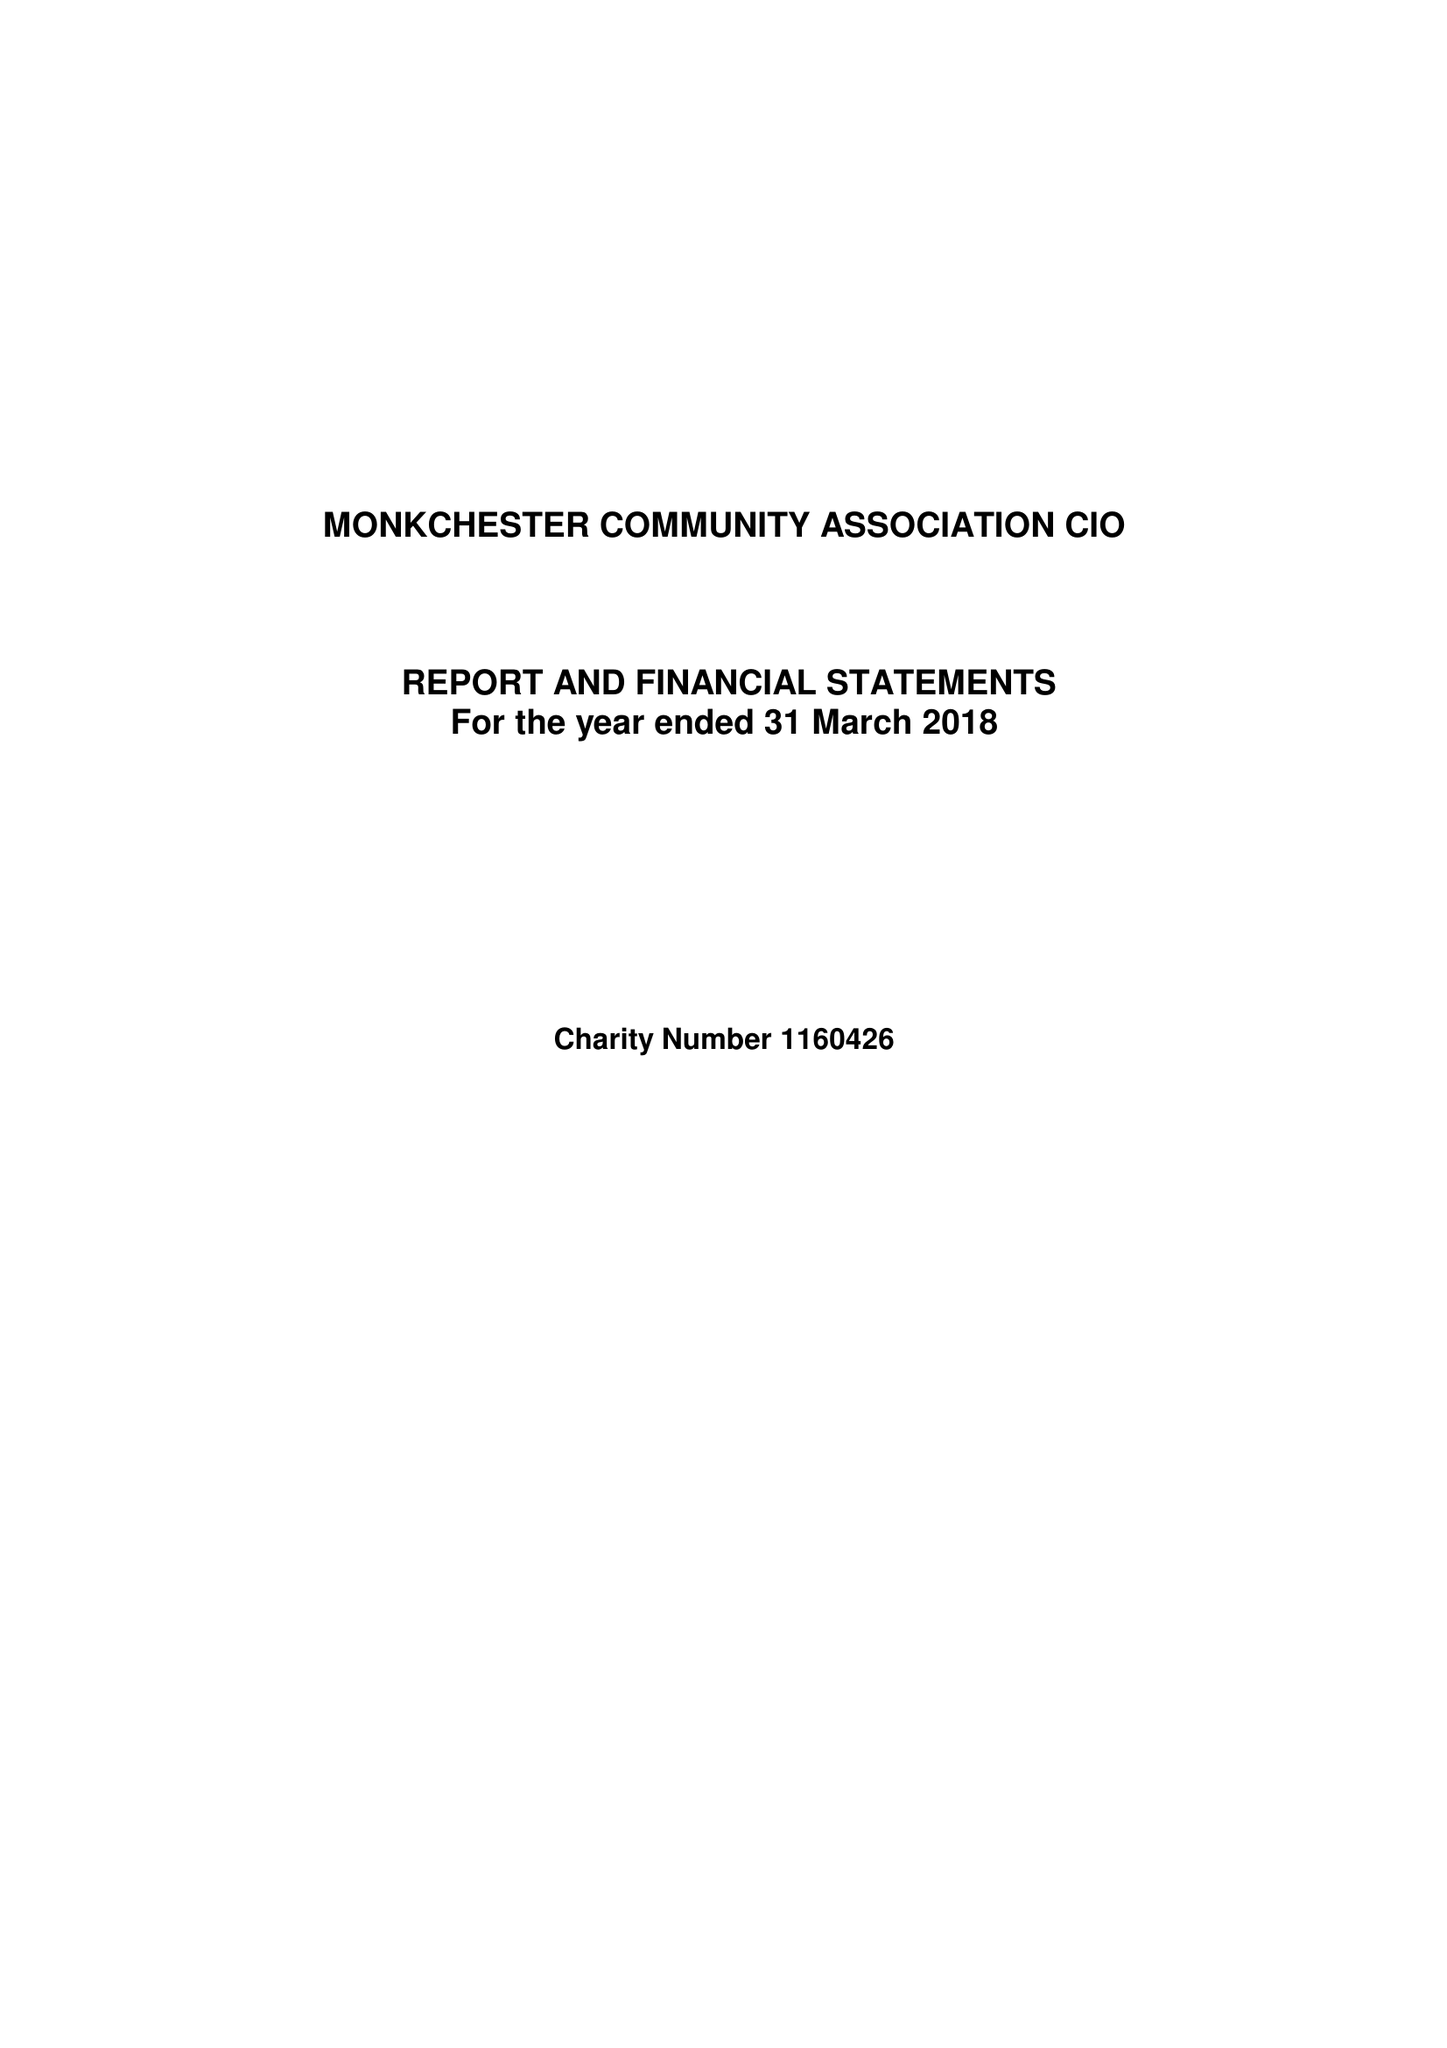What is the value for the spending_annually_in_british_pounds?
Answer the question using a single word or phrase. 22490.00 